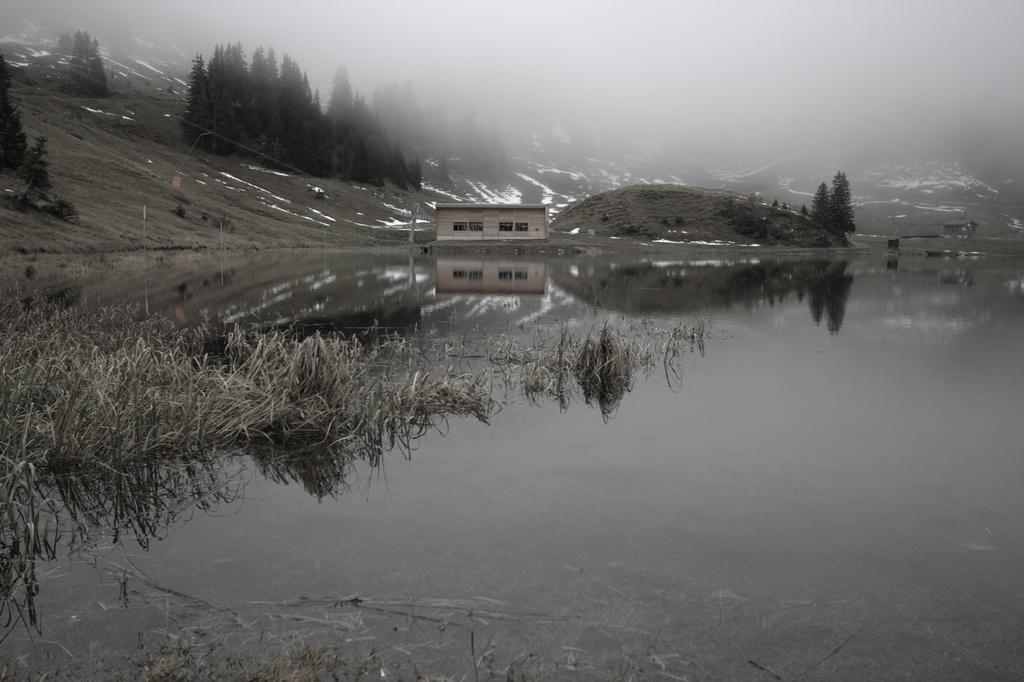Can you describe this image briefly? This image is clicked outside. At the bottom, there is water. On the left, there is grass. In the front, we can see a small house. In the background, there is a mountain along with trees and snow. At the top, there is fog. 